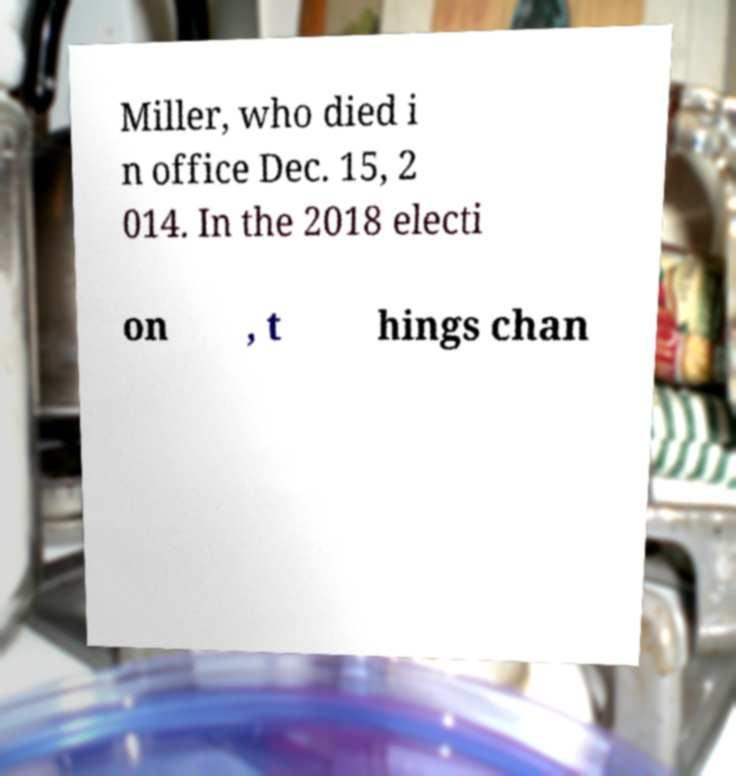Can you accurately transcribe the text from the provided image for me? Miller, who died i n office Dec. 15, 2 014. In the 2018 electi on , t hings chan 